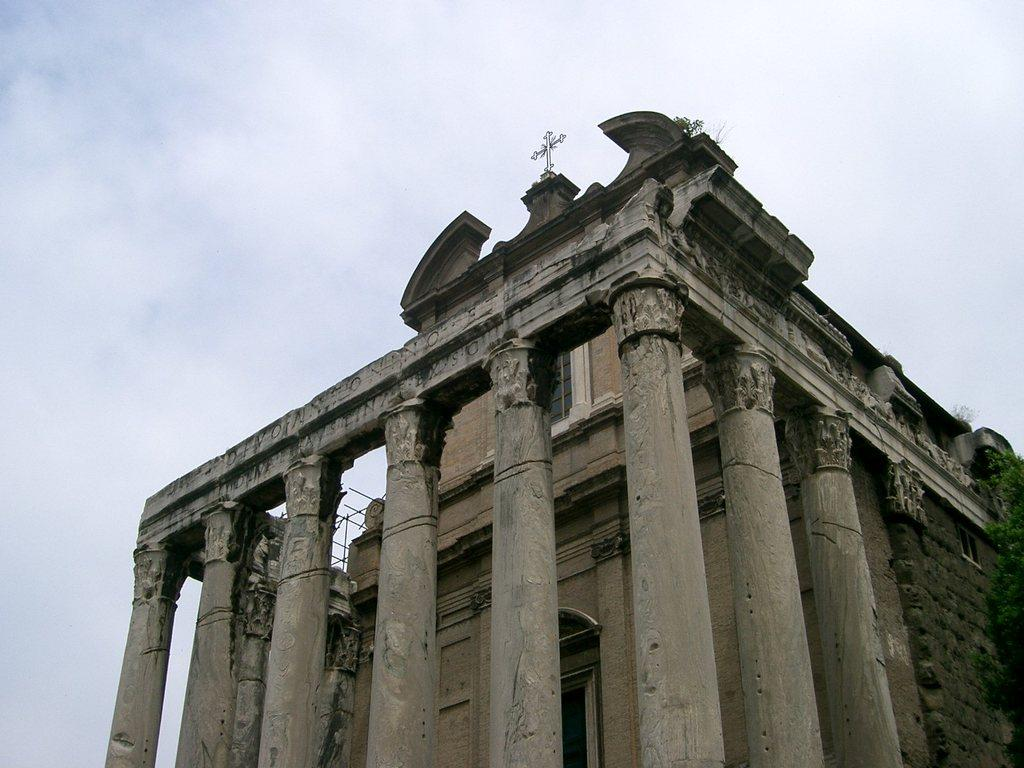What type of structure is depicted in the image? There is a building with pillars and windows in the image. Are there any natural elements present in the image? Yes, there is a tree in the right corner of the image. What can be seen in the background of the image? The sky is visible in the background of the image. What type of invention can be seen in the image? There is no invention present in the image; it features a building with pillars and windows, a tree, and the sky. What substance is being used by the frogs in the image? There are no frogs present in the image, so it is not possible to determine what substance they might be using. 